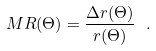Convert formula to latex. <formula><loc_0><loc_0><loc_500><loc_500>M R ( \Theta ) = \frac { \Delta r ( \Theta ) } { r ( \Theta ) } \ .</formula> 